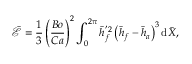<formula> <loc_0><loc_0><loc_500><loc_500>\bar { \mathcal { E } } = { \frac { 1 } { 3 } } \left ( { \frac { B o } { C a } } \right ) ^ { 2 } \int _ { 0 } ^ { 2 \pi } \bar { h } _ { f } ^ { ^ { \prime } 2 } \left ( \bar { h } _ { f } - \bar { h } _ { a } \right ) ^ { 3 } d \bar { X } ,</formula> 